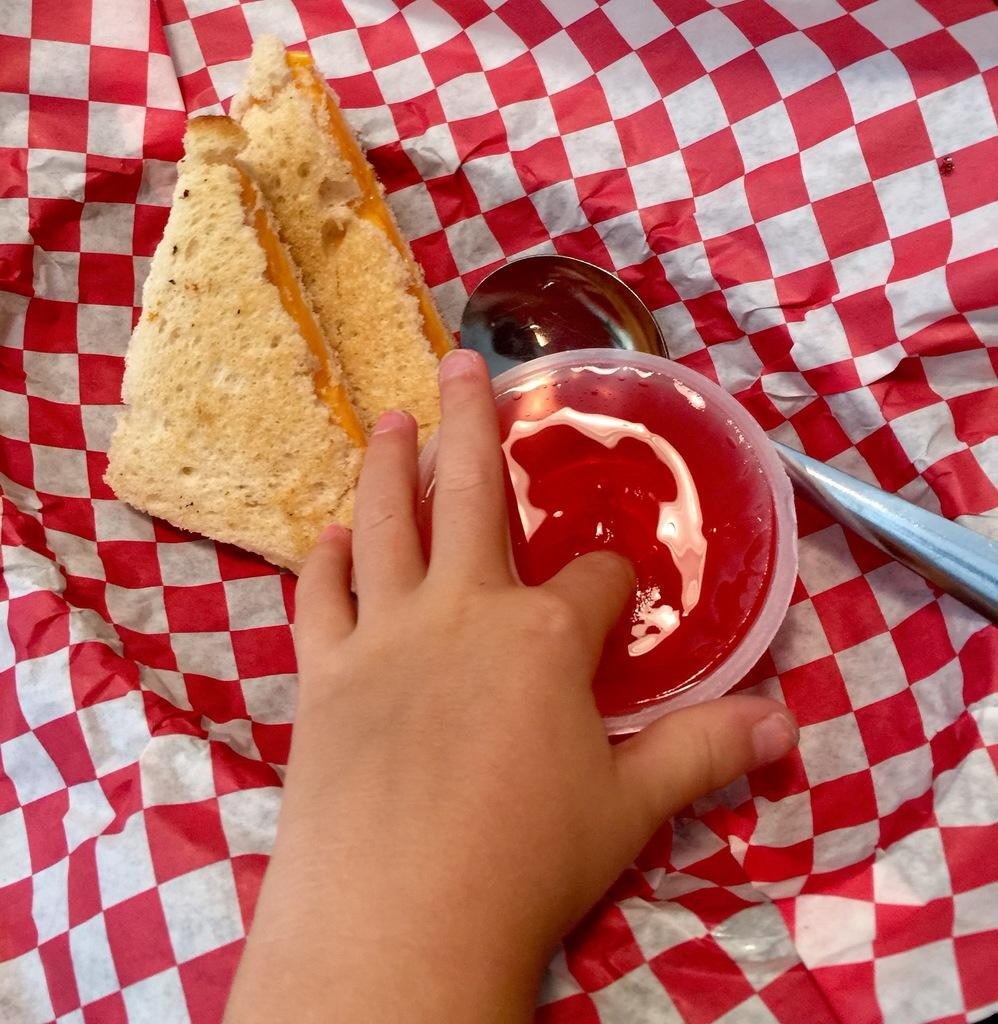What body part is visible in the image? There is a person's hand in the image. What type of food can be seen in the image? There are bread pieces in the image. What utensil is present in the image? There is a spoon in the image. What container is visible in the image? There is a cup in the image. What type of material is present in the image? There is a cloth in the image. How many tomatoes are tied in a knot in the image? There are no tomatoes or knots present in the image. What type of business is being conducted in the image? There is no indication of any business activity in the image. 